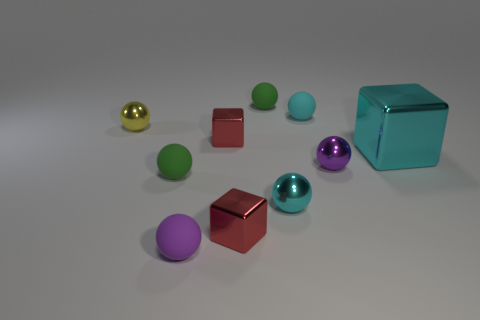There is a matte ball that is the same color as the big metal object; what size is it?
Keep it short and to the point. Small. How many other things are there of the same shape as the small cyan matte object?
Make the answer very short. 6. There is a purple matte object; is it the same size as the matte thing left of the purple rubber ball?
Provide a short and direct response. Yes. What number of things are red metallic objects or tiny purple things?
Ensure brevity in your answer.  4. How many other things are there of the same size as the cyan rubber object?
Offer a terse response. 8. There is a big thing; is its color the same as the matte ball that is on the right side of the cyan metal sphere?
Offer a terse response. Yes. How many blocks are small purple things or tiny cyan metallic things?
Give a very brief answer. 0. Is there any other thing that is the same color as the large object?
Provide a short and direct response. Yes. There is a small green object on the right side of the metallic cube in front of the large block; what is its material?
Give a very brief answer. Rubber. Do the tiny yellow ball and the red cube that is in front of the large metal object have the same material?
Offer a very short reply. Yes. 